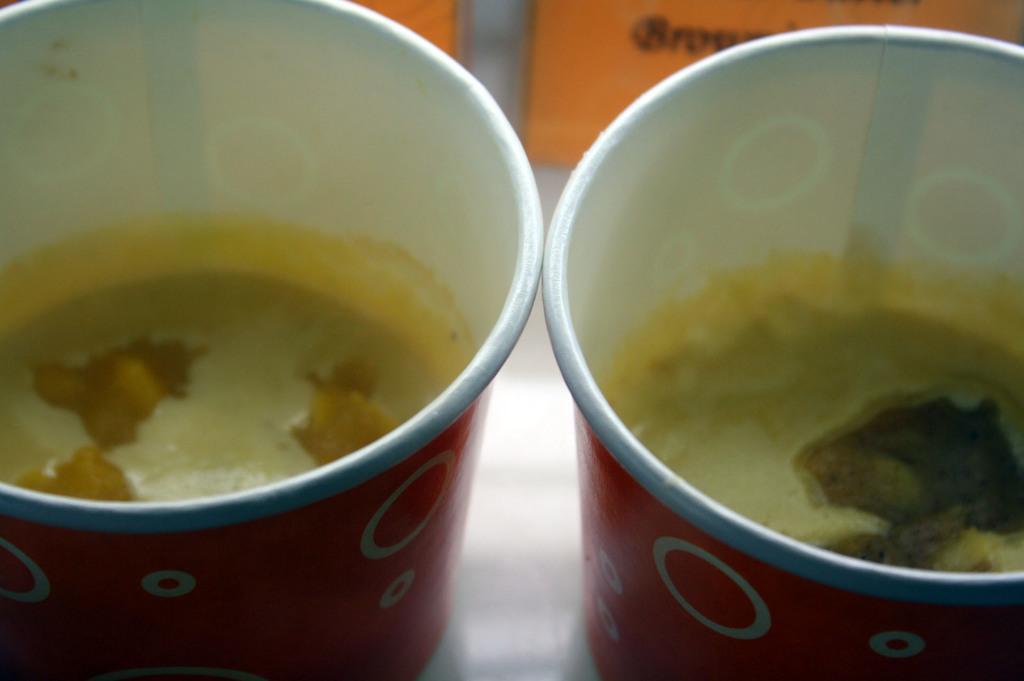How would you summarize this image in a sentence or two? In this image we can see some juice in the red color cups. Behind orange color thing is present. 